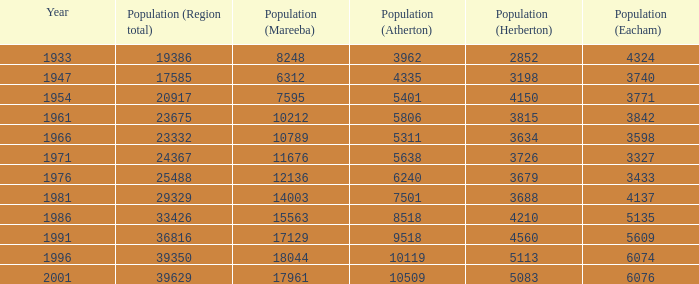What was the minimum population number for mareeba? 6312.0. 